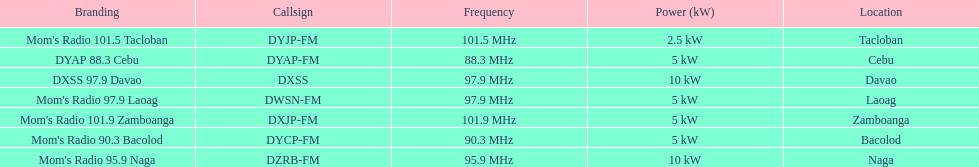What is the total number of stations with frequencies above 100 mhz? 2. 